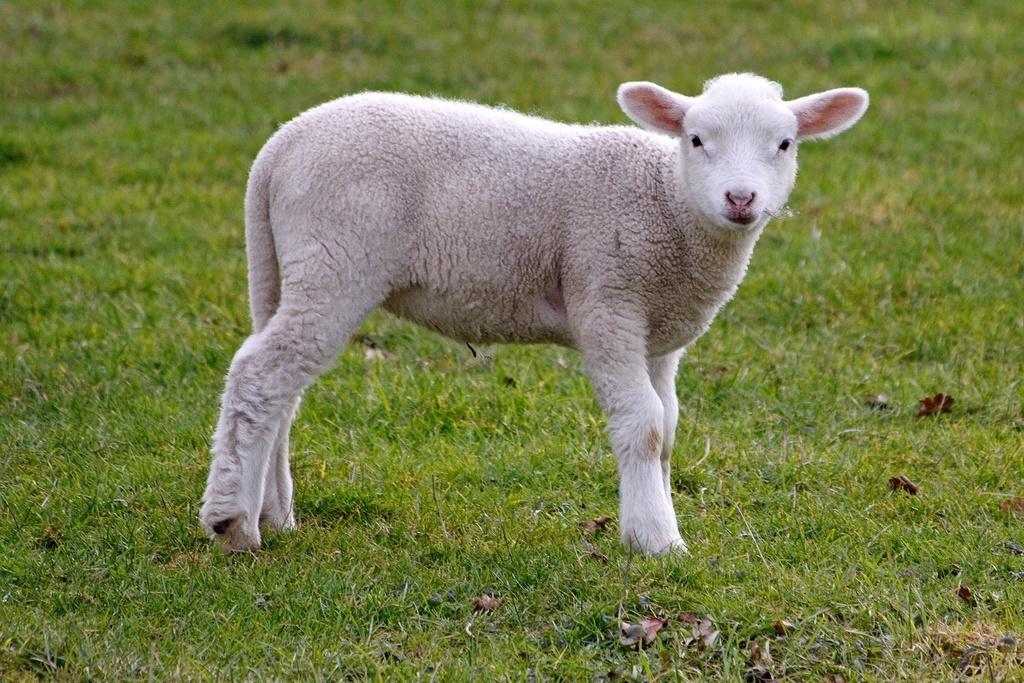Can you describe this image briefly? In this image there is a sheep standing on the grass. 